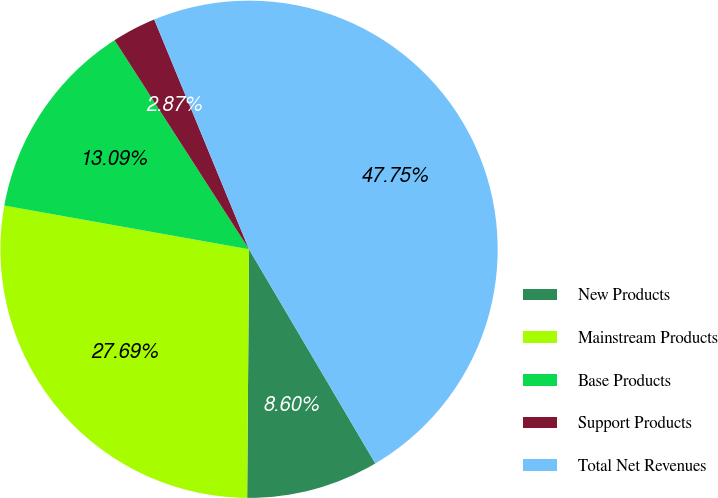<chart> <loc_0><loc_0><loc_500><loc_500><pie_chart><fcel>New Products<fcel>Mainstream Products<fcel>Base Products<fcel>Support Products<fcel>Total Net Revenues<nl><fcel>8.6%<fcel>27.7%<fcel>13.09%<fcel>2.87%<fcel>47.76%<nl></chart> 